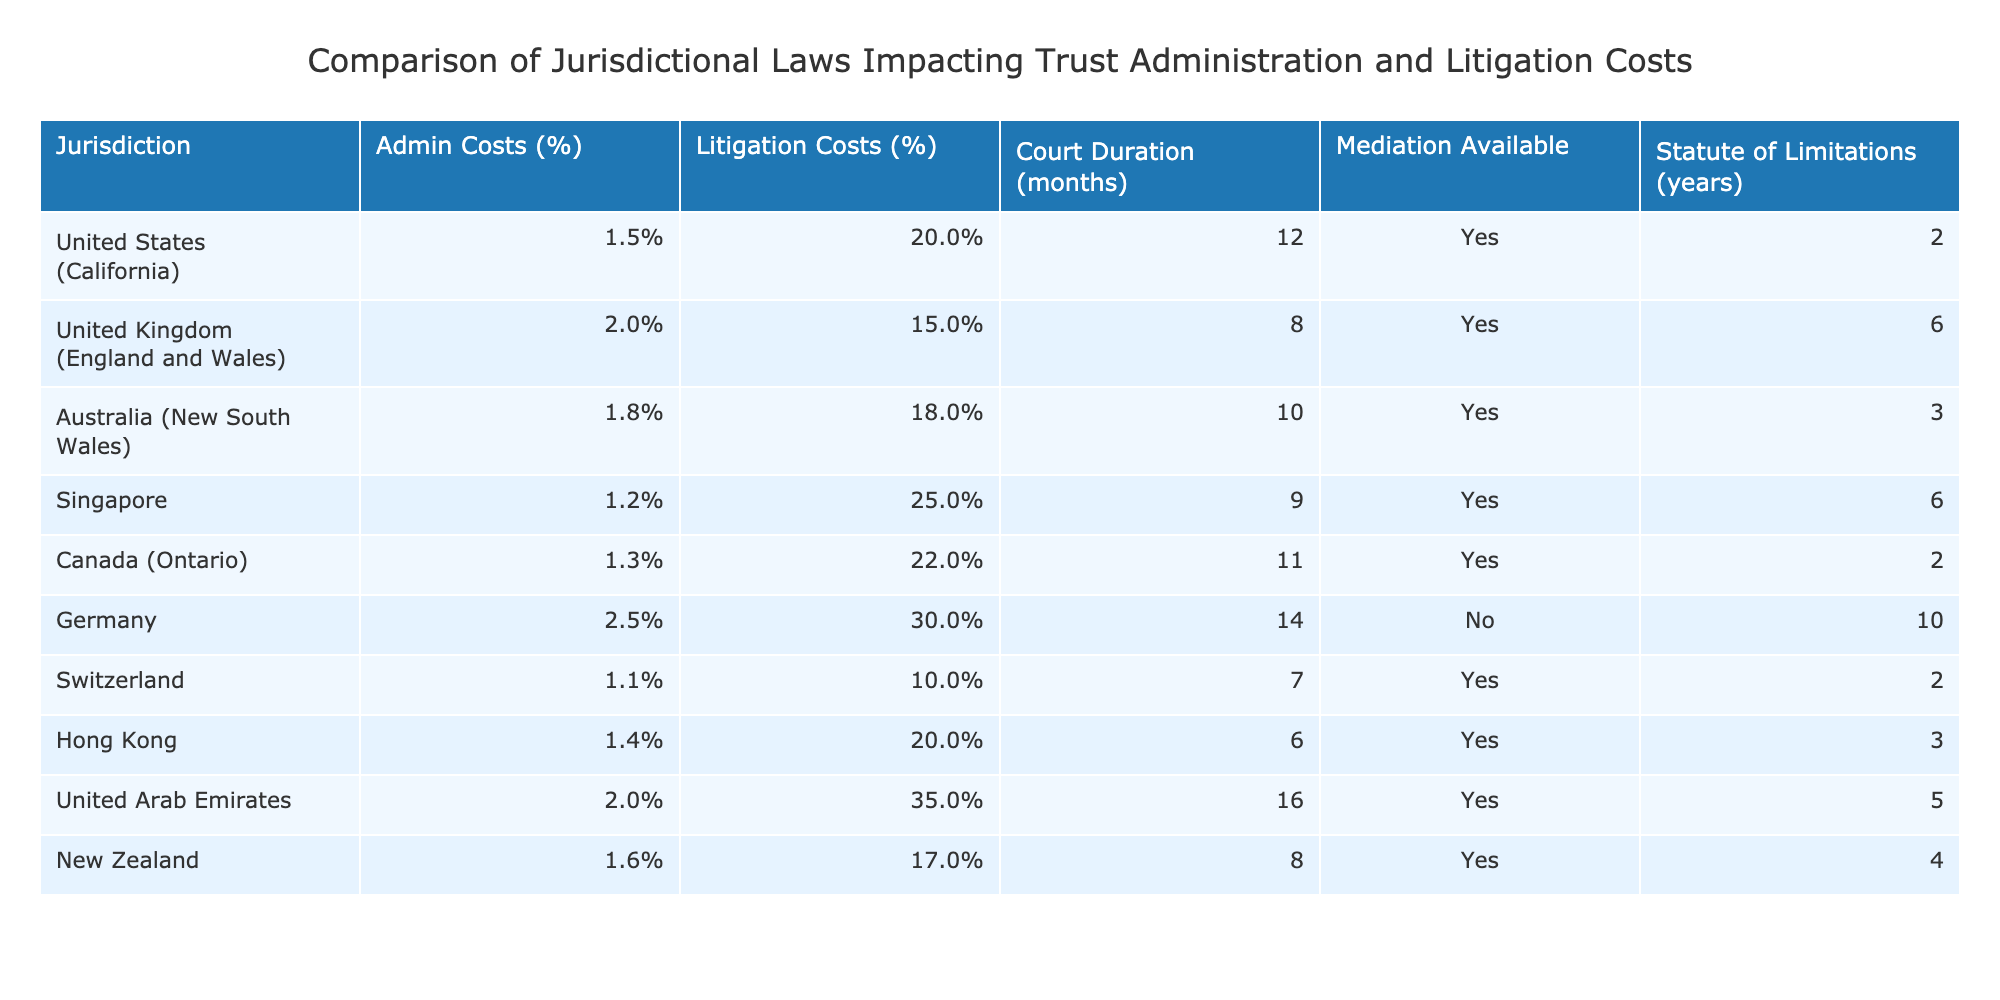What are the average trust administration costs in Germany? The average trust administration cost in Germany is listed in the table as 2.5% of the trust value.
Answer: 2.5% Which jurisdiction has the lowest average litigation costs? Looking at the table, Switzerland shows the lowest average litigation costs at 10% of the trust value.
Answer: 10% Is mediation available in all jurisdictions listed in the table? The table shows that mediation is available in the United States, United Kingdom, Australia, Singapore, Canada, Switzerland, Hong Kong, United Arab Emirates, and New Zealand, confirming that it is available in all except Germany.
Answer: No What is the statute of limitations for trust administration in Ontario? Ontario has a statute of limitations of 2 years. This value is taken directly from the table under the relevant jurisdiction.
Answer: 2 years If we consider the average litigation costs across the jurisdictions, which one shows the largest difference compared to the average costs of jurisdictions that have mediation available? The average litigation costs of the jurisdictions with mediation (2.5% + 1.5% + 1.8% + 25% + 22% + 20% + 35% + 17%) equal 17%. The difference when compared to Germany (30%) is 30% - 17% = 13%.
Answer: 13% Which jurisdiction has the highest court proceedings duration and how many months does it take? Referring to the table, the United Arab Emirates has the highest court proceedings duration listed as 16 months.
Answer: 16 months What is the average administration cost for jurisdictions with a statutory limitation period of 3 years or less? The applicable jurisdictions are the United States (1.5%), Canada (1.3%), New Zealand (1.6%), and Singapore (1.2%). The average is (1.5% + 1.3% + 1.6% + 1.2%) / 4 = 1.4%.
Answer: 1.4% Which jurisdiction exhibits both the highest administration costs and the longest court duration among those listed? Germany has the highest administration costs at 2.5% and the longest court duration at 14 months. Thus, it meets both criteria.
Answer: Germany What is the difference in average administration costs between the United States and the United Kingdom? The United States has an average administration cost of 1.5%, while the United Kingdom has 2%. The difference between these two costs is 2% - 1.5% = 0.5%.
Answer: 0.5% 